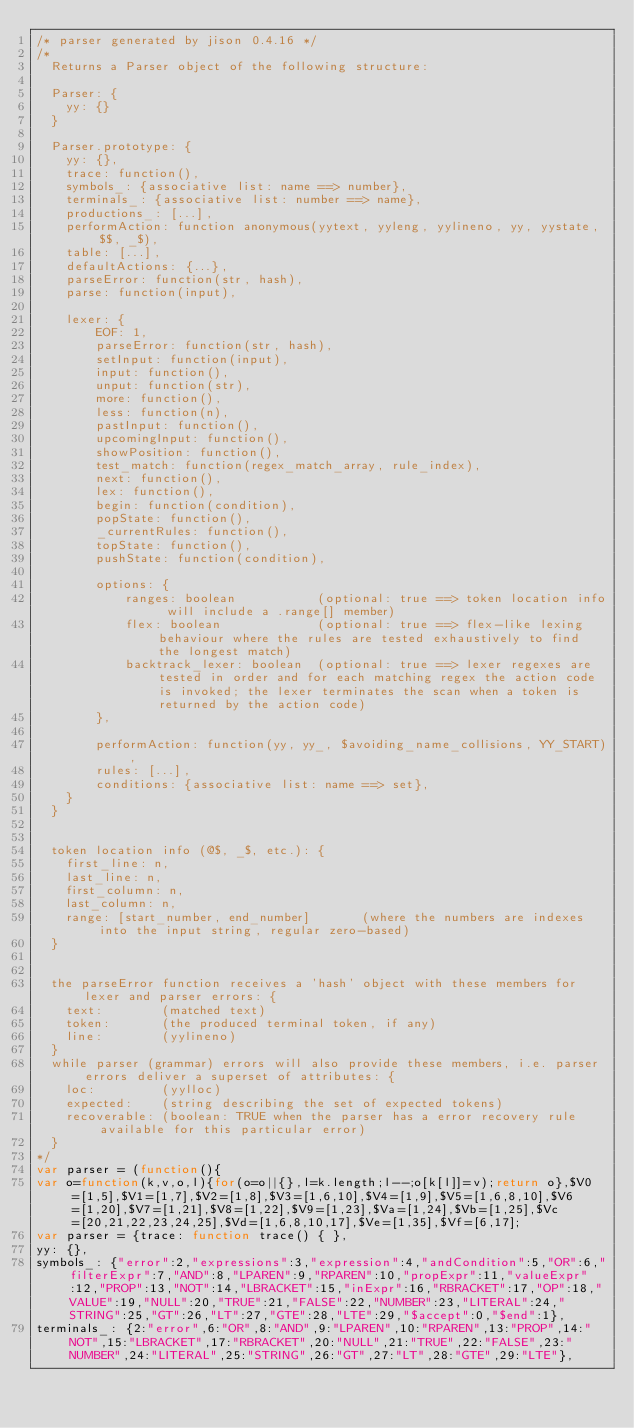<code> <loc_0><loc_0><loc_500><loc_500><_JavaScript_>/* parser generated by jison 0.4.16 */
/*
  Returns a Parser object of the following structure:

  Parser: {
    yy: {}
  }

  Parser.prototype: {
    yy: {},
    trace: function(),
    symbols_: {associative list: name ==> number},
    terminals_: {associative list: number ==> name},
    productions_: [...],
    performAction: function anonymous(yytext, yyleng, yylineno, yy, yystate, $$, _$),
    table: [...],
    defaultActions: {...},
    parseError: function(str, hash),
    parse: function(input),

    lexer: {
        EOF: 1,
        parseError: function(str, hash),
        setInput: function(input),
        input: function(),
        unput: function(str),
        more: function(),
        less: function(n),
        pastInput: function(),
        upcomingInput: function(),
        showPosition: function(),
        test_match: function(regex_match_array, rule_index),
        next: function(),
        lex: function(),
        begin: function(condition),
        popState: function(),
        _currentRules: function(),
        topState: function(),
        pushState: function(condition),

        options: {
            ranges: boolean           (optional: true ==> token location info will include a .range[] member)
            flex: boolean             (optional: true ==> flex-like lexing behaviour where the rules are tested exhaustively to find the longest match)
            backtrack_lexer: boolean  (optional: true ==> lexer regexes are tested in order and for each matching regex the action code is invoked; the lexer terminates the scan when a token is returned by the action code)
        },

        performAction: function(yy, yy_, $avoiding_name_collisions, YY_START),
        rules: [...],
        conditions: {associative list: name ==> set},
    }
  }


  token location info (@$, _$, etc.): {
    first_line: n,
    last_line: n,
    first_column: n,
    last_column: n,
    range: [start_number, end_number]       (where the numbers are indexes into the input string, regular zero-based)
  }


  the parseError function receives a 'hash' object with these members for lexer and parser errors: {
    text:        (matched text)
    token:       (the produced terminal token, if any)
    line:        (yylineno)
  }
  while parser (grammar) errors will also provide these members, i.e. parser errors deliver a superset of attributes: {
    loc:         (yylloc)
    expected:    (string describing the set of expected tokens)
    recoverable: (boolean: TRUE when the parser has a error recovery rule available for this particular error)
  }
*/
var parser = (function(){
var o=function(k,v,o,l){for(o=o||{},l=k.length;l--;o[k[l]]=v);return o},$V0=[1,5],$V1=[1,7],$V2=[1,8],$V3=[1,6,10],$V4=[1,9],$V5=[1,6,8,10],$V6=[1,20],$V7=[1,21],$V8=[1,22],$V9=[1,23],$Va=[1,24],$Vb=[1,25],$Vc=[20,21,22,23,24,25],$Vd=[1,6,8,10,17],$Ve=[1,35],$Vf=[6,17];
var parser = {trace: function trace() { },
yy: {},
symbols_: {"error":2,"expressions":3,"expression":4,"andCondition":5,"OR":6,"filterExpr":7,"AND":8,"LPAREN":9,"RPAREN":10,"propExpr":11,"valueExpr":12,"PROP":13,"NOT":14,"LBRACKET":15,"inExpr":16,"RBRACKET":17,"OP":18,"VALUE":19,"NULL":20,"TRUE":21,"FALSE":22,"NUMBER":23,"LITERAL":24,"STRING":25,"GT":26,"LT":27,"GTE":28,"LTE":29,"$accept":0,"$end":1},
terminals_: {2:"error",6:"OR",8:"AND",9:"LPAREN",10:"RPAREN",13:"PROP",14:"NOT",15:"LBRACKET",17:"RBRACKET",20:"NULL",21:"TRUE",22:"FALSE",23:"NUMBER",24:"LITERAL",25:"STRING",26:"GT",27:"LT",28:"GTE",29:"LTE"},</code> 